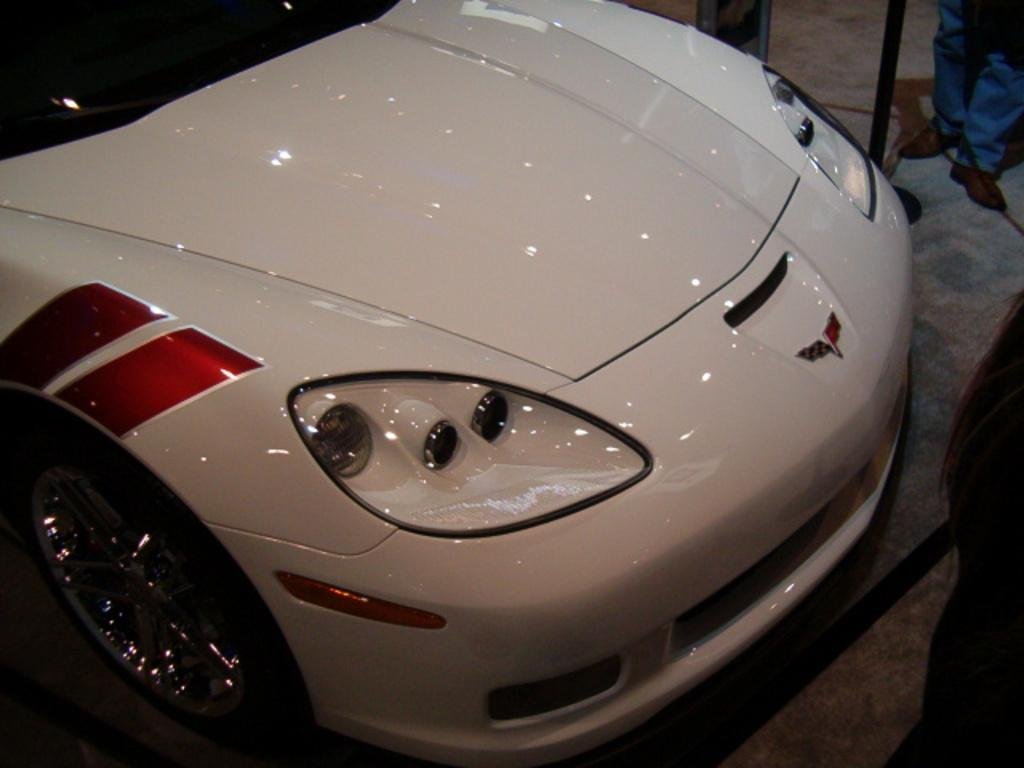What is the main subject of the image? There is a car in the image. Can you describe the people on the right side of the image? There are two people on the right side of the image. What else can be seen in the image besides the car and people? There is an object in the image. What is the surface on which the car and people are standing? There is a floor at the bottom of the image. Where is the patch of grass located in the image? There is no patch of grass present in the image. Can you describe the top of the car in the image? The provided facts do not mention the top of the car, so we cannot describe it. 